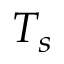Convert formula to latex. <formula><loc_0><loc_0><loc_500><loc_500>T _ { s }</formula> 